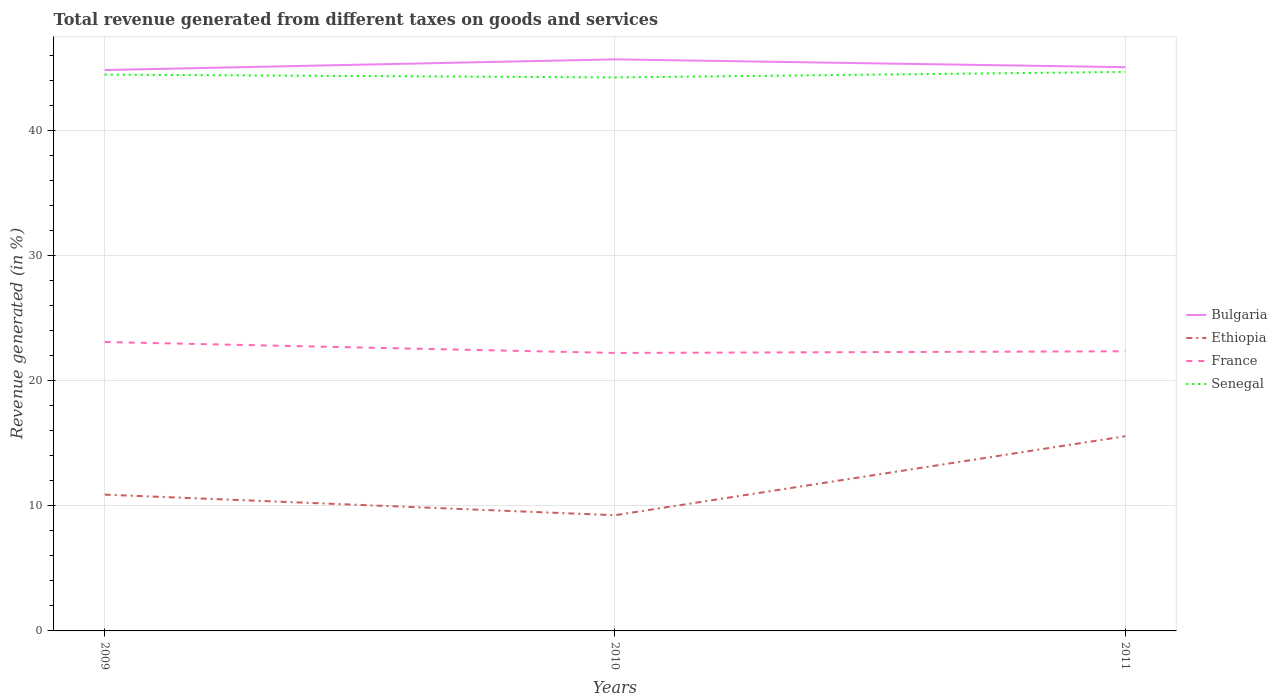Does the line corresponding to France intersect with the line corresponding to Bulgaria?
Your answer should be very brief. No. Is the number of lines equal to the number of legend labels?
Give a very brief answer. Yes. Across all years, what is the maximum total revenue generated in Bulgaria?
Make the answer very short. 44.81. What is the total total revenue generated in Bulgaria in the graph?
Your response must be concise. -0.23. What is the difference between the highest and the second highest total revenue generated in Ethiopia?
Give a very brief answer. 6.31. Is the total revenue generated in Senegal strictly greater than the total revenue generated in Bulgaria over the years?
Make the answer very short. Yes. How many lines are there?
Make the answer very short. 4. Are the values on the major ticks of Y-axis written in scientific E-notation?
Offer a terse response. No. What is the title of the graph?
Provide a succinct answer. Total revenue generated from different taxes on goods and services. What is the label or title of the Y-axis?
Keep it short and to the point. Revenue generated (in %). What is the Revenue generated (in %) in Bulgaria in 2009?
Your answer should be compact. 44.81. What is the Revenue generated (in %) of Ethiopia in 2009?
Your response must be concise. 10.89. What is the Revenue generated (in %) of France in 2009?
Make the answer very short. 23.08. What is the Revenue generated (in %) of Senegal in 2009?
Your response must be concise. 44.45. What is the Revenue generated (in %) in Bulgaria in 2010?
Your response must be concise. 45.67. What is the Revenue generated (in %) in Ethiopia in 2010?
Make the answer very short. 9.25. What is the Revenue generated (in %) in France in 2010?
Give a very brief answer. 22.21. What is the Revenue generated (in %) of Senegal in 2010?
Make the answer very short. 44.22. What is the Revenue generated (in %) of Bulgaria in 2011?
Ensure brevity in your answer.  45.04. What is the Revenue generated (in %) of Ethiopia in 2011?
Your answer should be very brief. 15.56. What is the Revenue generated (in %) of France in 2011?
Your response must be concise. 22.34. What is the Revenue generated (in %) in Senegal in 2011?
Your response must be concise. 44.66. Across all years, what is the maximum Revenue generated (in %) of Bulgaria?
Ensure brevity in your answer.  45.67. Across all years, what is the maximum Revenue generated (in %) in Ethiopia?
Ensure brevity in your answer.  15.56. Across all years, what is the maximum Revenue generated (in %) in France?
Your answer should be very brief. 23.08. Across all years, what is the maximum Revenue generated (in %) of Senegal?
Provide a short and direct response. 44.66. Across all years, what is the minimum Revenue generated (in %) in Bulgaria?
Keep it short and to the point. 44.81. Across all years, what is the minimum Revenue generated (in %) in Ethiopia?
Make the answer very short. 9.25. Across all years, what is the minimum Revenue generated (in %) in France?
Your response must be concise. 22.21. Across all years, what is the minimum Revenue generated (in %) in Senegal?
Ensure brevity in your answer.  44.22. What is the total Revenue generated (in %) in Bulgaria in the graph?
Offer a very short reply. 135.52. What is the total Revenue generated (in %) of Ethiopia in the graph?
Ensure brevity in your answer.  35.69. What is the total Revenue generated (in %) in France in the graph?
Provide a short and direct response. 67.64. What is the total Revenue generated (in %) of Senegal in the graph?
Give a very brief answer. 133.34. What is the difference between the Revenue generated (in %) of Bulgaria in 2009 and that in 2010?
Ensure brevity in your answer.  -0.85. What is the difference between the Revenue generated (in %) of Ethiopia in 2009 and that in 2010?
Provide a short and direct response. 1.64. What is the difference between the Revenue generated (in %) in Senegal in 2009 and that in 2010?
Your answer should be compact. 0.23. What is the difference between the Revenue generated (in %) of Bulgaria in 2009 and that in 2011?
Your answer should be compact. -0.23. What is the difference between the Revenue generated (in %) in Ethiopia in 2009 and that in 2011?
Provide a short and direct response. -4.67. What is the difference between the Revenue generated (in %) of France in 2009 and that in 2011?
Ensure brevity in your answer.  0.74. What is the difference between the Revenue generated (in %) in Senegal in 2009 and that in 2011?
Ensure brevity in your answer.  -0.22. What is the difference between the Revenue generated (in %) of Bulgaria in 2010 and that in 2011?
Offer a terse response. 0.62. What is the difference between the Revenue generated (in %) in Ethiopia in 2010 and that in 2011?
Your answer should be very brief. -6.31. What is the difference between the Revenue generated (in %) in France in 2010 and that in 2011?
Your answer should be very brief. -0.13. What is the difference between the Revenue generated (in %) of Senegal in 2010 and that in 2011?
Make the answer very short. -0.44. What is the difference between the Revenue generated (in %) of Bulgaria in 2009 and the Revenue generated (in %) of Ethiopia in 2010?
Offer a terse response. 35.57. What is the difference between the Revenue generated (in %) of Bulgaria in 2009 and the Revenue generated (in %) of France in 2010?
Ensure brevity in your answer.  22.61. What is the difference between the Revenue generated (in %) of Bulgaria in 2009 and the Revenue generated (in %) of Senegal in 2010?
Ensure brevity in your answer.  0.59. What is the difference between the Revenue generated (in %) of Ethiopia in 2009 and the Revenue generated (in %) of France in 2010?
Make the answer very short. -11.32. What is the difference between the Revenue generated (in %) in Ethiopia in 2009 and the Revenue generated (in %) in Senegal in 2010?
Ensure brevity in your answer.  -33.33. What is the difference between the Revenue generated (in %) in France in 2009 and the Revenue generated (in %) in Senegal in 2010?
Provide a succinct answer. -21.14. What is the difference between the Revenue generated (in %) in Bulgaria in 2009 and the Revenue generated (in %) in Ethiopia in 2011?
Make the answer very short. 29.26. What is the difference between the Revenue generated (in %) of Bulgaria in 2009 and the Revenue generated (in %) of France in 2011?
Make the answer very short. 22.47. What is the difference between the Revenue generated (in %) of Bulgaria in 2009 and the Revenue generated (in %) of Senegal in 2011?
Provide a succinct answer. 0.15. What is the difference between the Revenue generated (in %) of Ethiopia in 2009 and the Revenue generated (in %) of France in 2011?
Offer a very short reply. -11.45. What is the difference between the Revenue generated (in %) of Ethiopia in 2009 and the Revenue generated (in %) of Senegal in 2011?
Make the answer very short. -33.77. What is the difference between the Revenue generated (in %) in France in 2009 and the Revenue generated (in %) in Senegal in 2011?
Offer a terse response. -21.58. What is the difference between the Revenue generated (in %) of Bulgaria in 2010 and the Revenue generated (in %) of Ethiopia in 2011?
Offer a very short reply. 30.11. What is the difference between the Revenue generated (in %) in Bulgaria in 2010 and the Revenue generated (in %) in France in 2011?
Your answer should be very brief. 23.32. What is the difference between the Revenue generated (in %) in Bulgaria in 2010 and the Revenue generated (in %) in Senegal in 2011?
Make the answer very short. 1. What is the difference between the Revenue generated (in %) in Ethiopia in 2010 and the Revenue generated (in %) in France in 2011?
Your response must be concise. -13.1. What is the difference between the Revenue generated (in %) in Ethiopia in 2010 and the Revenue generated (in %) in Senegal in 2011?
Provide a succinct answer. -35.42. What is the difference between the Revenue generated (in %) of France in 2010 and the Revenue generated (in %) of Senegal in 2011?
Your answer should be very brief. -22.46. What is the average Revenue generated (in %) in Bulgaria per year?
Your response must be concise. 45.17. What is the average Revenue generated (in %) in Ethiopia per year?
Provide a short and direct response. 11.9. What is the average Revenue generated (in %) of France per year?
Give a very brief answer. 22.55. What is the average Revenue generated (in %) of Senegal per year?
Make the answer very short. 44.45. In the year 2009, what is the difference between the Revenue generated (in %) in Bulgaria and Revenue generated (in %) in Ethiopia?
Your answer should be very brief. 33.93. In the year 2009, what is the difference between the Revenue generated (in %) in Bulgaria and Revenue generated (in %) in France?
Offer a terse response. 21.73. In the year 2009, what is the difference between the Revenue generated (in %) of Bulgaria and Revenue generated (in %) of Senegal?
Provide a succinct answer. 0.37. In the year 2009, what is the difference between the Revenue generated (in %) of Ethiopia and Revenue generated (in %) of France?
Your response must be concise. -12.19. In the year 2009, what is the difference between the Revenue generated (in %) in Ethiopia and Revenue generated (in %) in Senegal?
Provide a short and direct response. -33.56. In the year 2009, what is the difference between the Revenue generated (in %) of France and Revenue generated (in %) of Senegal?
Your answer should be compact. -21.36. In the year 2010, what is the difference between the Revenue generated (in %) of Bulgaria and Revenue generated (in %) of Ethiopia?
Make the answer very short. 36.42. In the year 2010, what is the difference between the Revenue generated (in %) of Bulgaria and Revenue generated (in %) of France?
Make the answer very short. 23.46. In the year 2010, what is the difference between the Revenue generated (in %) of Bulgaria and Revenue generated (in %) of Senegal?
Your response must be concise. 1.44. In the year 2010, what is the difference between the Revenue generated (in %) of Ethiopia and Revenue generated (in %) of France?
Ensure brevity in your answer.  -12.96. In the year 2010, what is the difference between the Revenue generated (in %) in Ethiopia and Revenue generated (in %) in Senegal?
Offer a terse response. -34.98. In the year 2010, what is the difference between the Revenue generated (in %) in France and Revenue generated (in %) in Senegal?
Offer a terse response. -22.01. In the year 2011, what is the difference between the Revenue generated (in %) of Bulgaria and Revenue generated (in %) of Ethiopia?
Make the answer very short. 29.49. In the year 2011, what is the difference between the Revenue generated (in %) of Bulgaria and Revenue generated (in %) of France?
Ensure brevity in your answer.  22.7. In the year 2011, what is the difference between the Revenue generated (in %) of Bulgaria and Revenue generated (in %) of Senegal?
Ensure brevity in your answer.  0.38. In the year 2011, what is the difference between the Revenue generated (in %) of Ethiopia and Revenue generated (in %) of France?
Provide a succinct answer. -6.79. In the year 2011, what is the difference between the Revenue generated (in %) in Ethiopia and Revenue generated (in %) in Senegal?
Provide a succinct answer. -29.11. In the year 2011, what is the difference between the Revenue generated (in %) in France and Revenue generated (in %) in Senegal?
Offer a terse response. -22.32. What is the ratio of the Revenue generated (in %) in Bulgaria in 2009 to that in 2010?
Ensure brevity in your answer.  0.98. What is the ratio of the Revenue generated (in %) in Ethiopia in 2009 to that in 2010?
Your answer should be very brief. 1.18. What is the ratio of the Revenue generated (in %) of France in 2009 to that in 2010?
Your answer should be very brief. 1.04. What is the ratio of the Revenue generated (in %) in Bulgaria in 2009 to that in 2011?
Offer a very short reply. 0.99. What is the ratio of the Revenue generated (in %) in France in 2009 to that in 2011?
Ensure brevity in your answer.  1.03. What is the ratio of the Revenue generated (in %) of Senegal in 2009 to that in 2011?
Provide a succinct answer. 1. What is the ratio of the Revenue generated (in %) of Bulgaria in 2010 to that in 2011?
Your answer should be compact. 1.01. What is the ratio of the Revenue generated (in %) of Ethiopia in 2010 to that in 2011?
Make the answer very short. 0.59. What is the ratio of the Revenue generated (in %) of France in 2010 to that in 2011?
Give a very brief answer. 0.99. What is the ratio of the Revenue generated (in %) in Senegal in 2010 to that in 2011?
Offer a terse response. 0.99. What is the difference between the highest and the second highest Revenue generated (in %) of Bulgaria?
Your answer should be compact. 0.62. What is the difference between the highest and the second highest Revenue generated (in %) in Ethiopia?
Your answer should be compact. 4.67. What is the difference between the highest and the second highest Revenue generated (in %) of France?
Offer a very short reply. 0.74. What is the difference between the highest and the second highest Revenue generated (in %) of Senegal?
Your response must be concise. 0.22. What is the difference between the highest and the lowest Revenue generated (in %) of Bulgaria?
Ensure brevity in your answer.  0.85. What is the difference between the highest and the lowest Revenue generated (in %) of Ethiopia?
Your answer should be compact. 6.31. What is the difference between the highest and the lowest Revenue generated (in %) of France?
Ensure brevity in your answer.  0.88. What is the difference between the highest and the lowest Revenue generated (in %) of Senegal?
Ensure brevity in your answer.  0.44. 